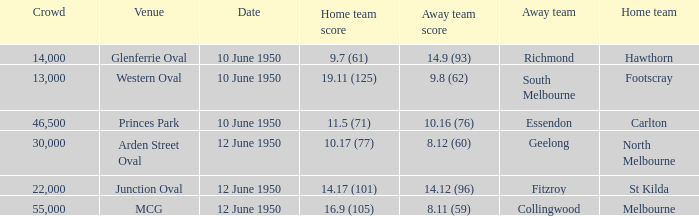Who was the away team when the VFL played at MCG? Collingwood. 